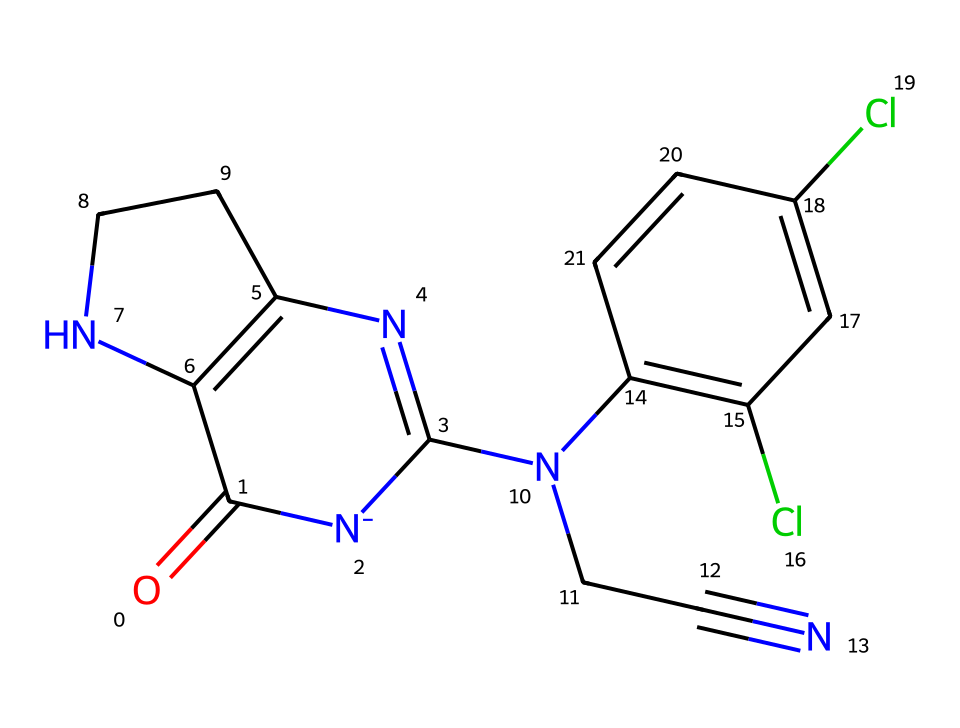What is the main functional group present in this chemical? The chemical structure reveals a nitro group (highlighted by the presence of nitrogen and surrounding atoms), indicating its activity as a pesticide.
Answer: nitro How many nitrogen atoms are present in the structure? By counting the nitrogen (N) atoms visible in the structure, there are three nitrogen atoms in total.
Answer: three Which elements are present in the molecular structure? Investigating the chemical's parts shows that it contains carbon (C), hydrogen (H), nitrogen (N), oxygen (O), and chlorine (Cl) atoms.
Answer: carbon, hydrogen, nitrogen, oxygen, chlorine What type of pesticide is indicated by this structure? The presence of a nitro group and a structure similar to nicotine indicates that this compound is a neonicotinoid, which is known for its insecticidal properties.
Answer: neonicotinoid How might this chemical impact bee populations? Given its classification as a neonicotinoid, which has been linked to harmful effects on bee behavior and survival, this chemical likely poses risks to bee populations.
Answer: harmful effect What is the total number of rings in the chemical structure? The structure contains two distinct rings, which can be identified by observing the cyclic arrangements of atoms.
Answer: two 